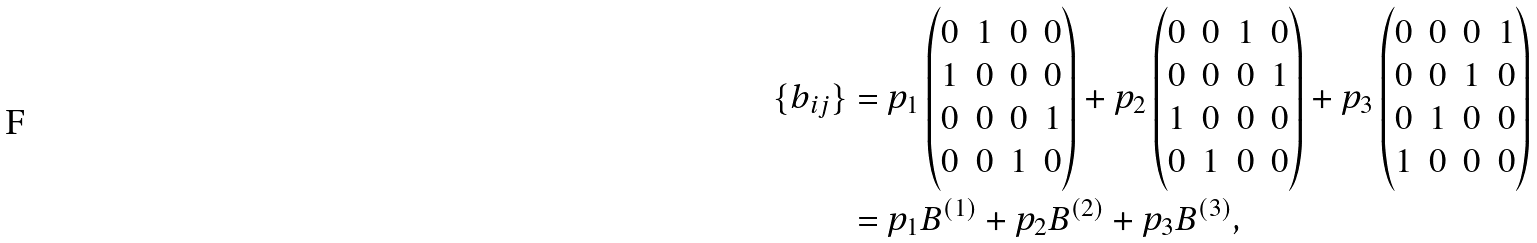Convert formula to latex. <formula><loc_0><loc_0><loc_500><loc_500>\{ b _ { i j } \} & = p _ { 1 } \begin{pmatrix} 0 & 1 & 0 & 0 \\ 1 & 0 & 0 & 0 \\ 0 & 0 & 0 & 1 \\ 0 & 0 & 1 & 0 \end{pmatrix} + p _ { 2 } \begin{pmatrix} 0 & 0 & 1 & 0 \\ 0 & 0 & 0 & 1 \\ 1 & 0 & 0 & 0 \\ 0 & 1 & 0 & 0 \end{pmatrix} + p _ { 3 } \begin{pmatrix} 0 & 0 & 0 & 1 \\ 0 & 0 & 1 & 0 \\ 0 & 1 & 0 & 0 \\ 1 & 0 & 0 & 0 \end{pmatrix} \\ & = p _ { 1 } B ^ { ( 1 ) } + p _ { 2 } B ^ { ( 2 ) } + p _ { 3 } B ^ { ( 3 ) } ,</formula> 